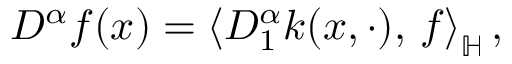<formula> <loc_0><loc_0><loc_500><loc_500>D ^ { \alpha } f ( x ) = \left \langle D _ { 1 } ^ { \alpha } k ( x , \cdot ) , \, f \right \rangle _ { \mathbb { H } } ,</formula> 